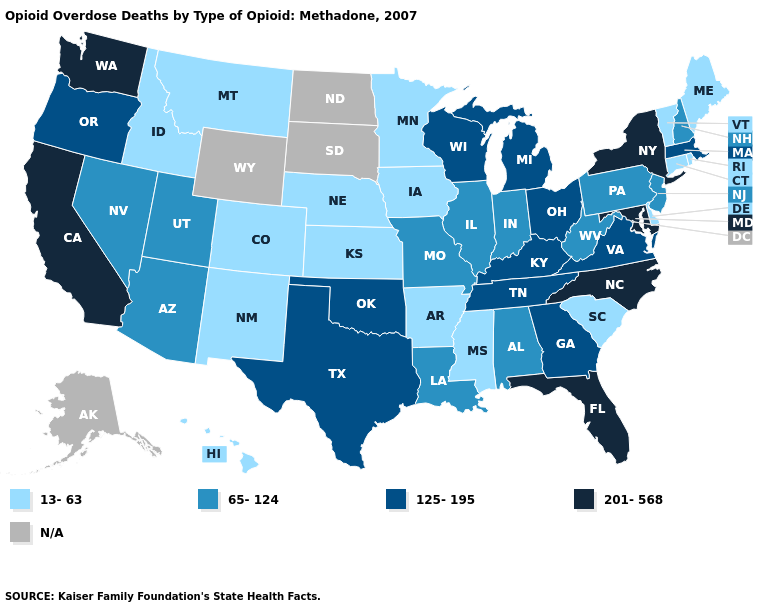Among the states that border Idaho , which have the highest value?
Be succinct. Washington. Which states have the lowest value in the USA?
Write a very short answer. Arkansas, Colorado, Connecticut, Delaware, Hawaii, Idaho, Iowa, Kansas, Maine, Minnesota, Mississippi, Montana, Nebraska, New Mexico, Rhode Island, South Carolina, Vermont. Does South Carolina have the lowest value in the South?
Give a very brief answer. Yes. Name the states that have a value in the range 125-195?
Be succinct. Georgia, Kentucky, Massachusetts, Michigan, Ohio, Oklahoma, Oregon, Tennessee, Texas, Virginia, Wisconsin. Name the states that have a value in the range 65-124?
Concise answer only. Alabama, Arizona, Illinois, Indiana, Louisiana, Missouri, Nevada, New Hampshire, New Jersey, Pennsylvania, Utah, West Virginia. Name the states that have a value in the range 125-195?
Answer briefly. Georgia, Kentucky, Massachusetts, Michigan, Ohio, Oklahoma, Oregon, Tennessee, Texas, Virginia, Wisconsin. Name the states that have a value in the range 201-568?
Quick response, please. California, Florida, Maryland, New York, North Carolina, Washington. Name the states that have a value in the range 125-195?
Be succinct. Georgia, Kentucky, Massachusetts, Michigan, Ohio, Oklahoma, Oregon, Tennessee, Texas, Virginia, Wisconsin. Among the states that border Massachusetts , does Vermont have the highest value?
Keep it brief. No. Among the states that border Michigan , does Wisconsin have the lowest value?
Concise answer only. No. What is the highest value in states that border Indiana?
Keep it brief. 125-195. Name the states that have a value in the range 65-124?
Write a very short answer. Alabama, Arizona, Illinois, Indiana, Louisiana, Missouri, Nevada, New Hampshire, New Jersey, Pennsylvania, Utah, West Virginia. Name the states that have a value in the range 65-124?
Give a very brief answer. Alabama, Arizona, Illinois, Indiana, Louisiana, Missouri, Nevada, New Hampshire, New Jersey, Pennsylvania, Utah, West Virginia. Which states hav the highest value in the Northeast?
Write a very short answer. New York. 